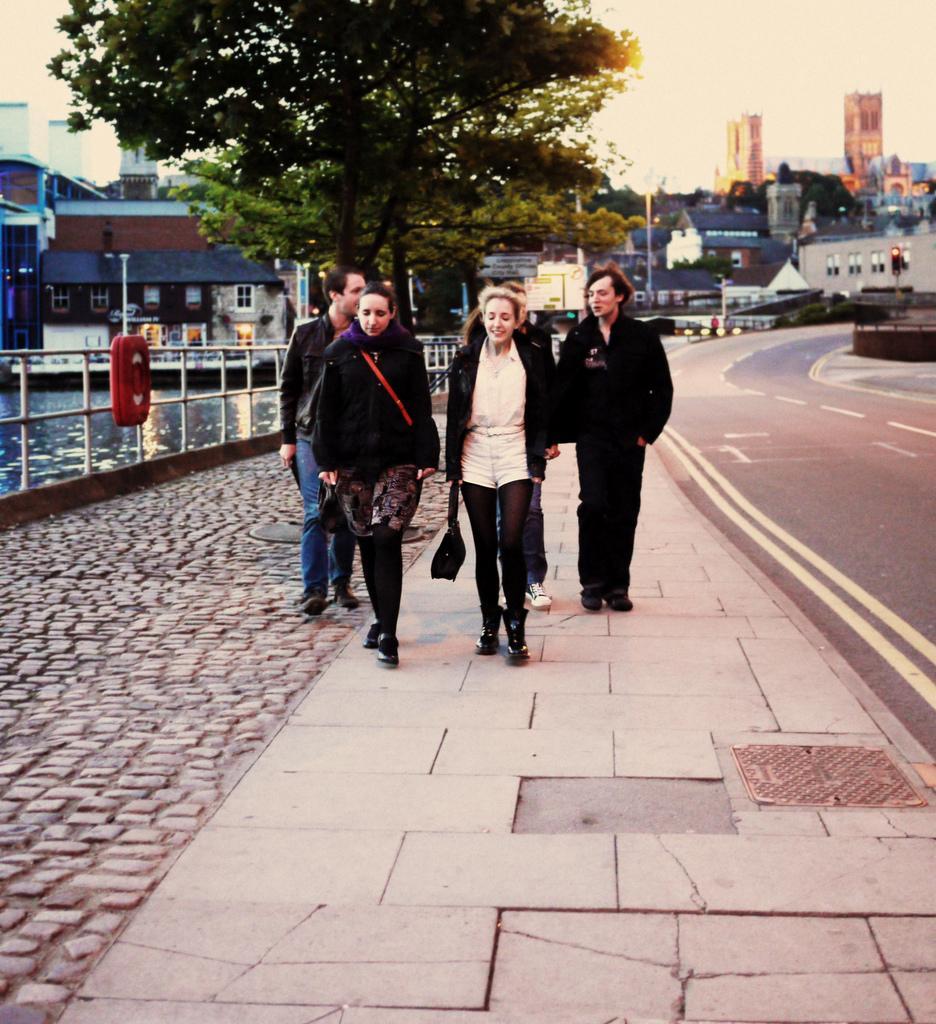Can you describe this image briefly? In this image there are a few people walking on the pavement of the road, beside them there is a railing, beside the railing there is a river. In the background there are buildings, trees, poles and the sky. 